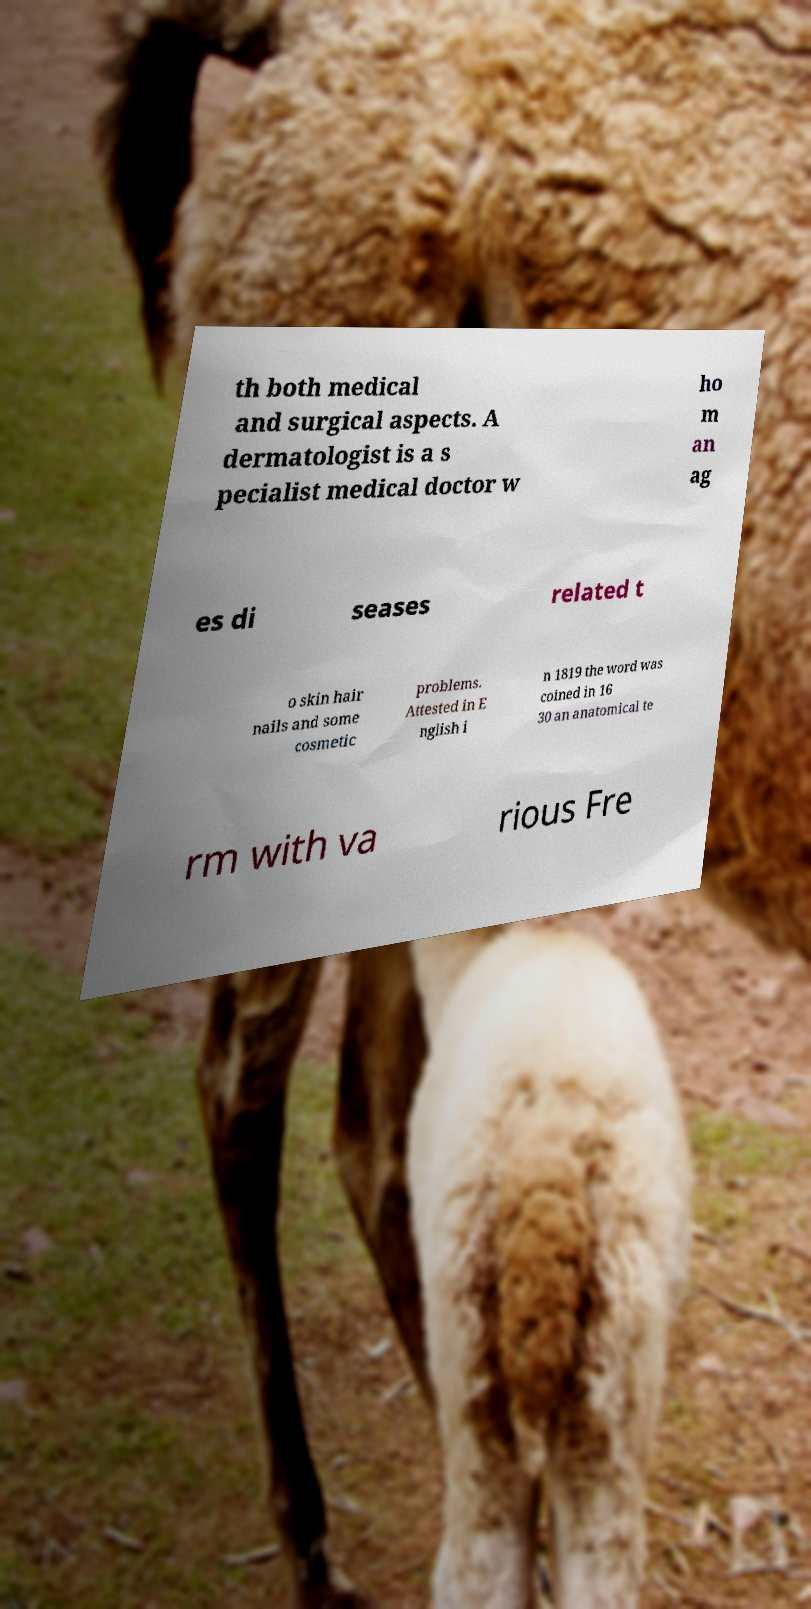What messages or text are displayed in this image? I need them in a readable, typed format. th both medical and surgical aspects. A dermatologist is a s pecialist medical doctor w ho m an ag es di seases related t o skin hair nails and some cosmetic problems. Attested in E nglish i n 1819 the word was coined in 16 30 an anatomical te rm with va rious Fre 